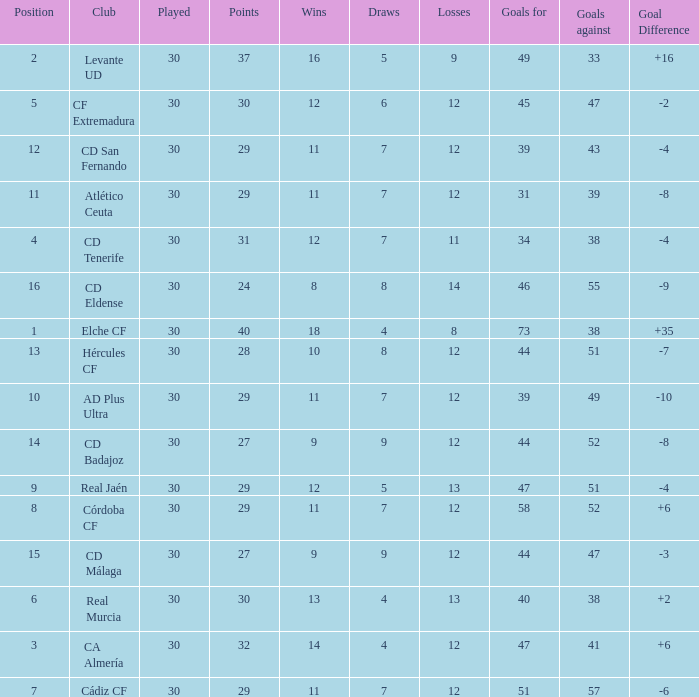What is the total number of losses with less than 73 goals for, less than 11 wins, more than 24 points, and a position greater than 15? 0.0. 